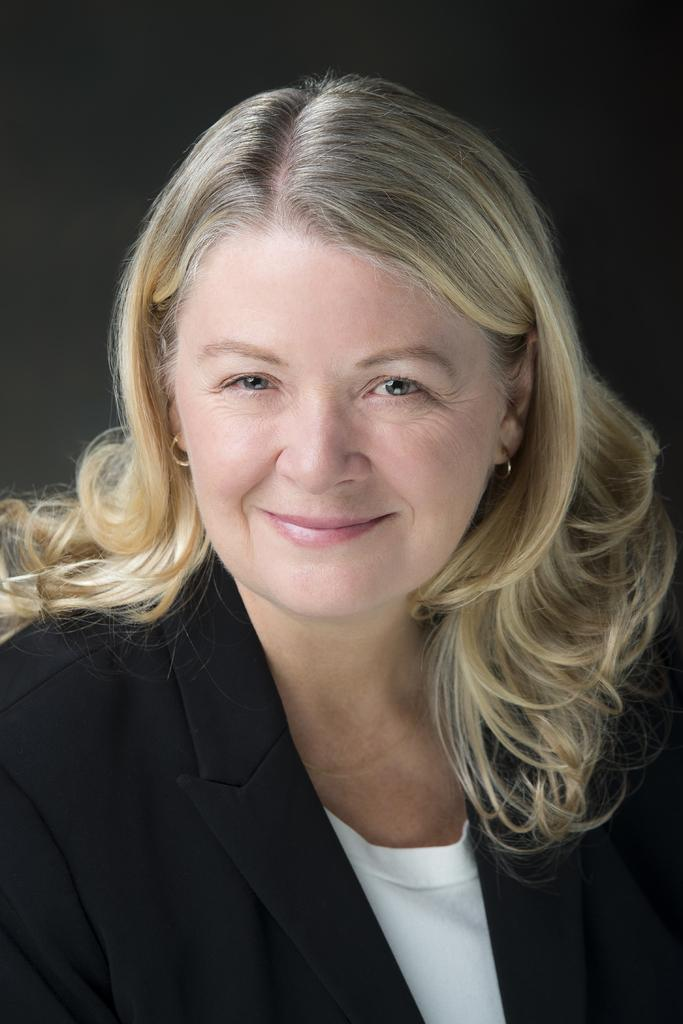What is the main subject of the image? The main subject of the image is a woman. What is the woman's facial expression in the image? The woman is smiling in the image. What can be observed about the background of the image? The background of the image is dark. How many birds are visible in the image? There are no birds present in the image. Is there a baby visible in the image? There is no baby present in the image. Is the woman in the image depicted as being in jail? There is no indication in the image that the woman is in jail. 